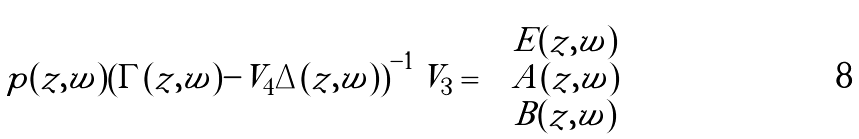<formula> <loc_0><loc_0><loc_500><loc_500>p ( z , w ) \left ( \Gamma ( z , w ) - V _ { 4 } \Delta ( z , w ) \right ) ^ { - 1 } V _ { 3 } = \begin{pmatrix} E ( z , w ) \\ A ( z , w ) \\ B ( z , w ) \end{pmatrix}</formula> 